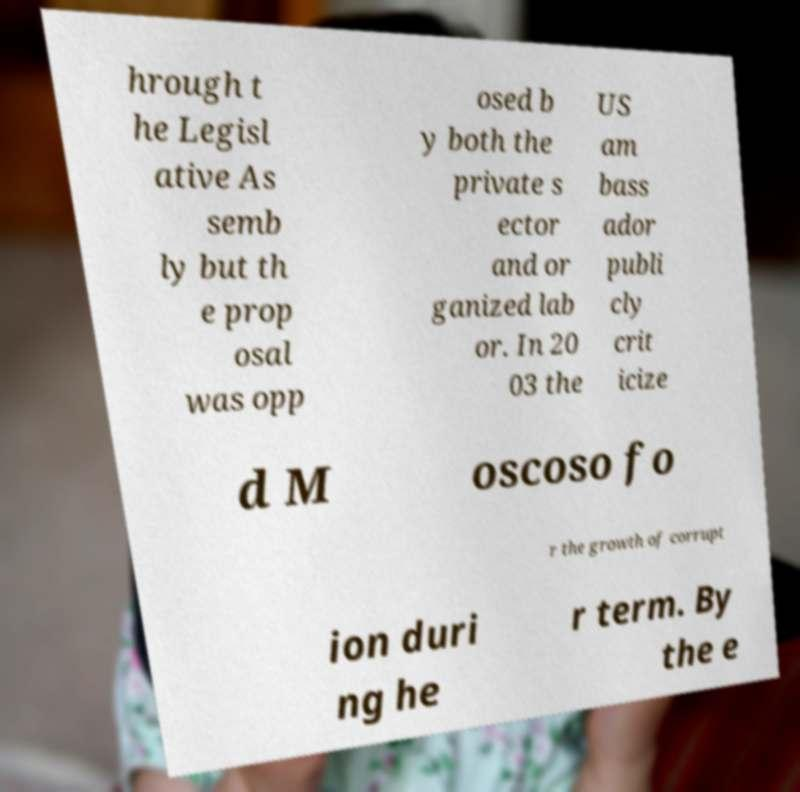Can you accurately transcribe the text from the provided image for me? hrough t he Legisl ative As semb ly but th e prop osal was opp osed b y both the private s ector and or ganized lab or. In 20 03 the US am bass ador publi cly crit icize d M oscoso fo r the growth of corrupt ion duri ng he r term. By the e 